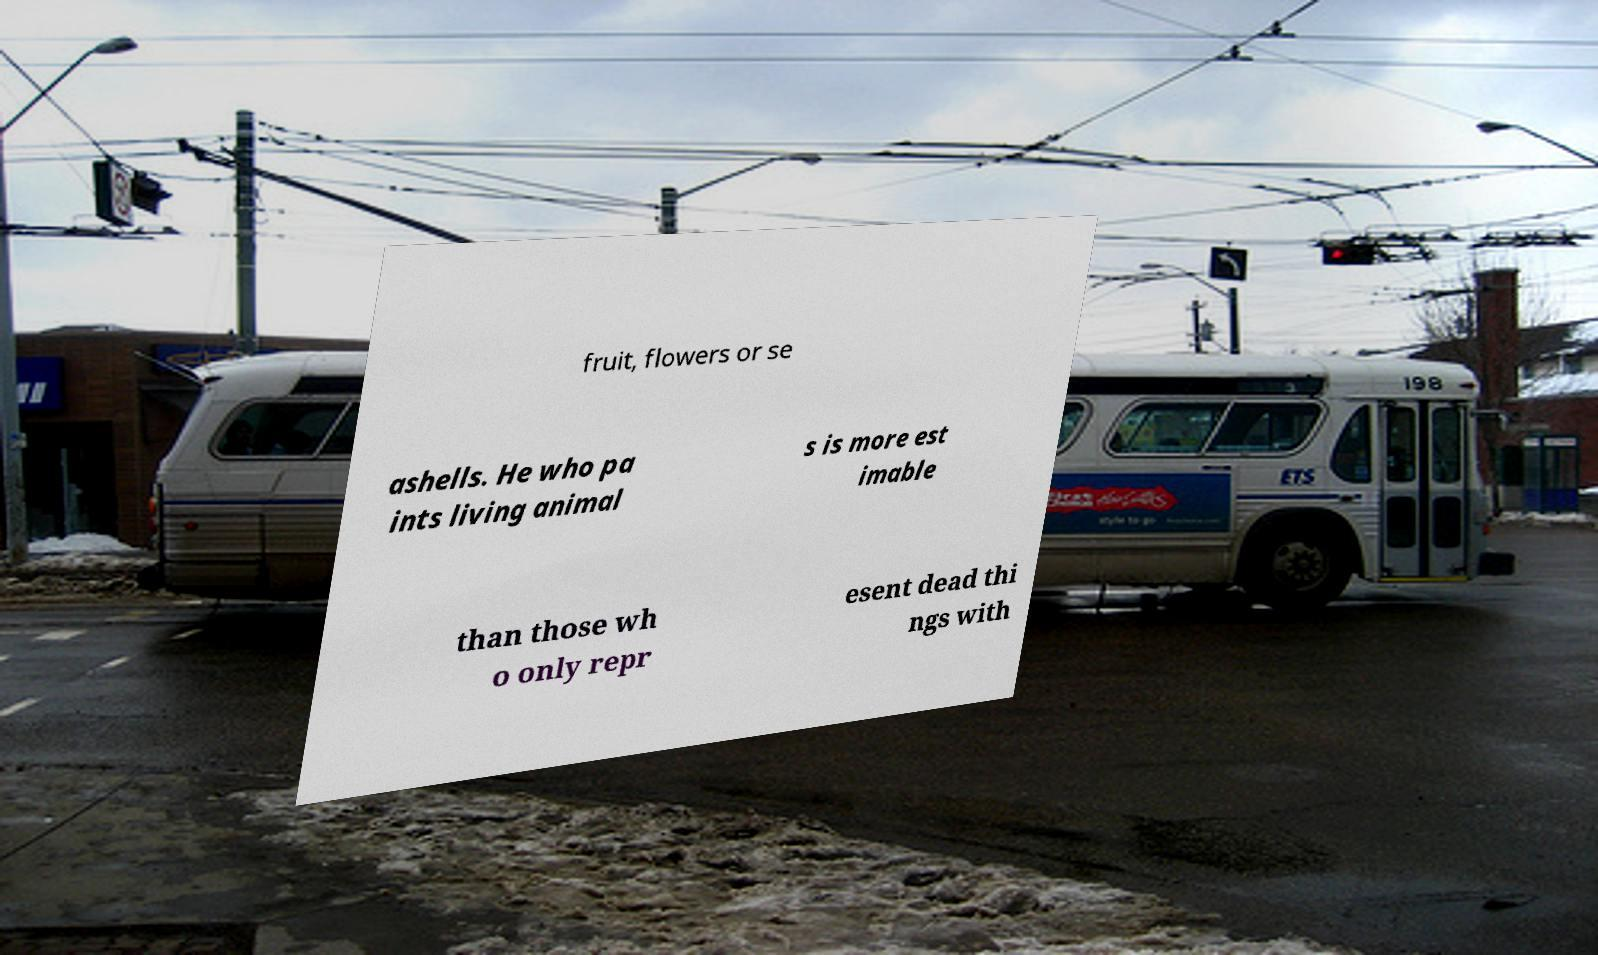There's text embedded in this image that I need extracted. Can you transcribe it verbatim? fruit, flowers or se ashells. He who pa ints living animal s is more est imable than those wh o only repr esent dead thi ngs with 